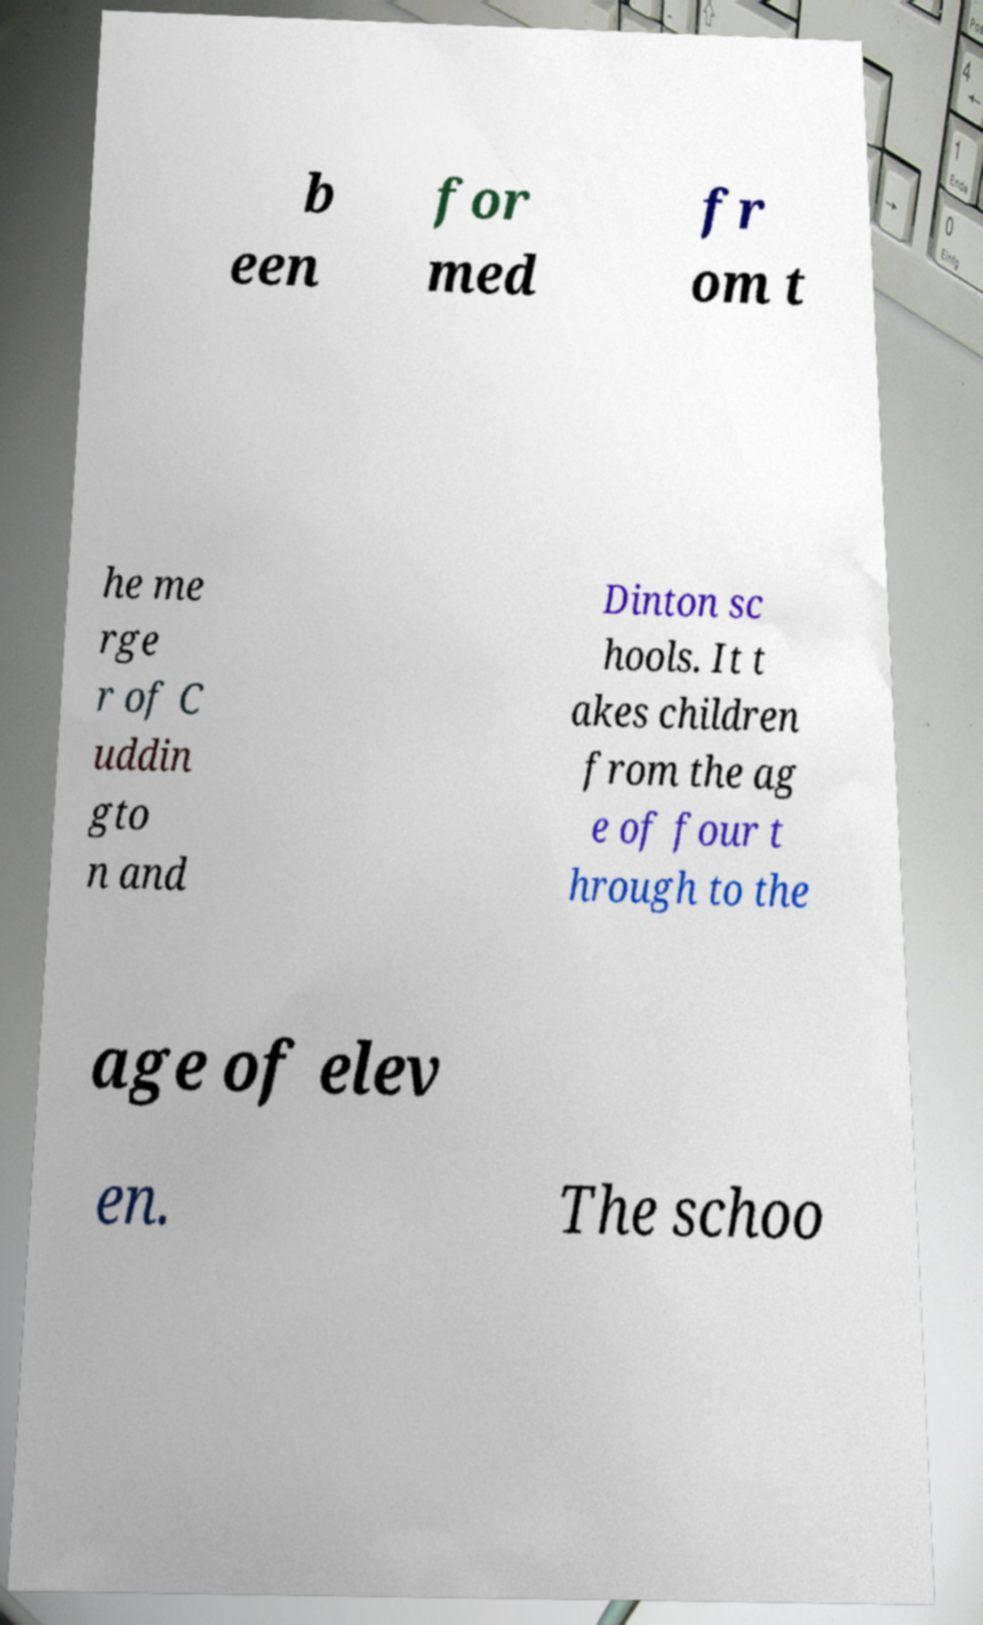Please identify and transcribe the text found in this image. b een for med fr om t he me rge r of C uddin gto n and Dinton sc hools. It t akes children from the ag e of four t hrough to the age of elev en. The schoo 